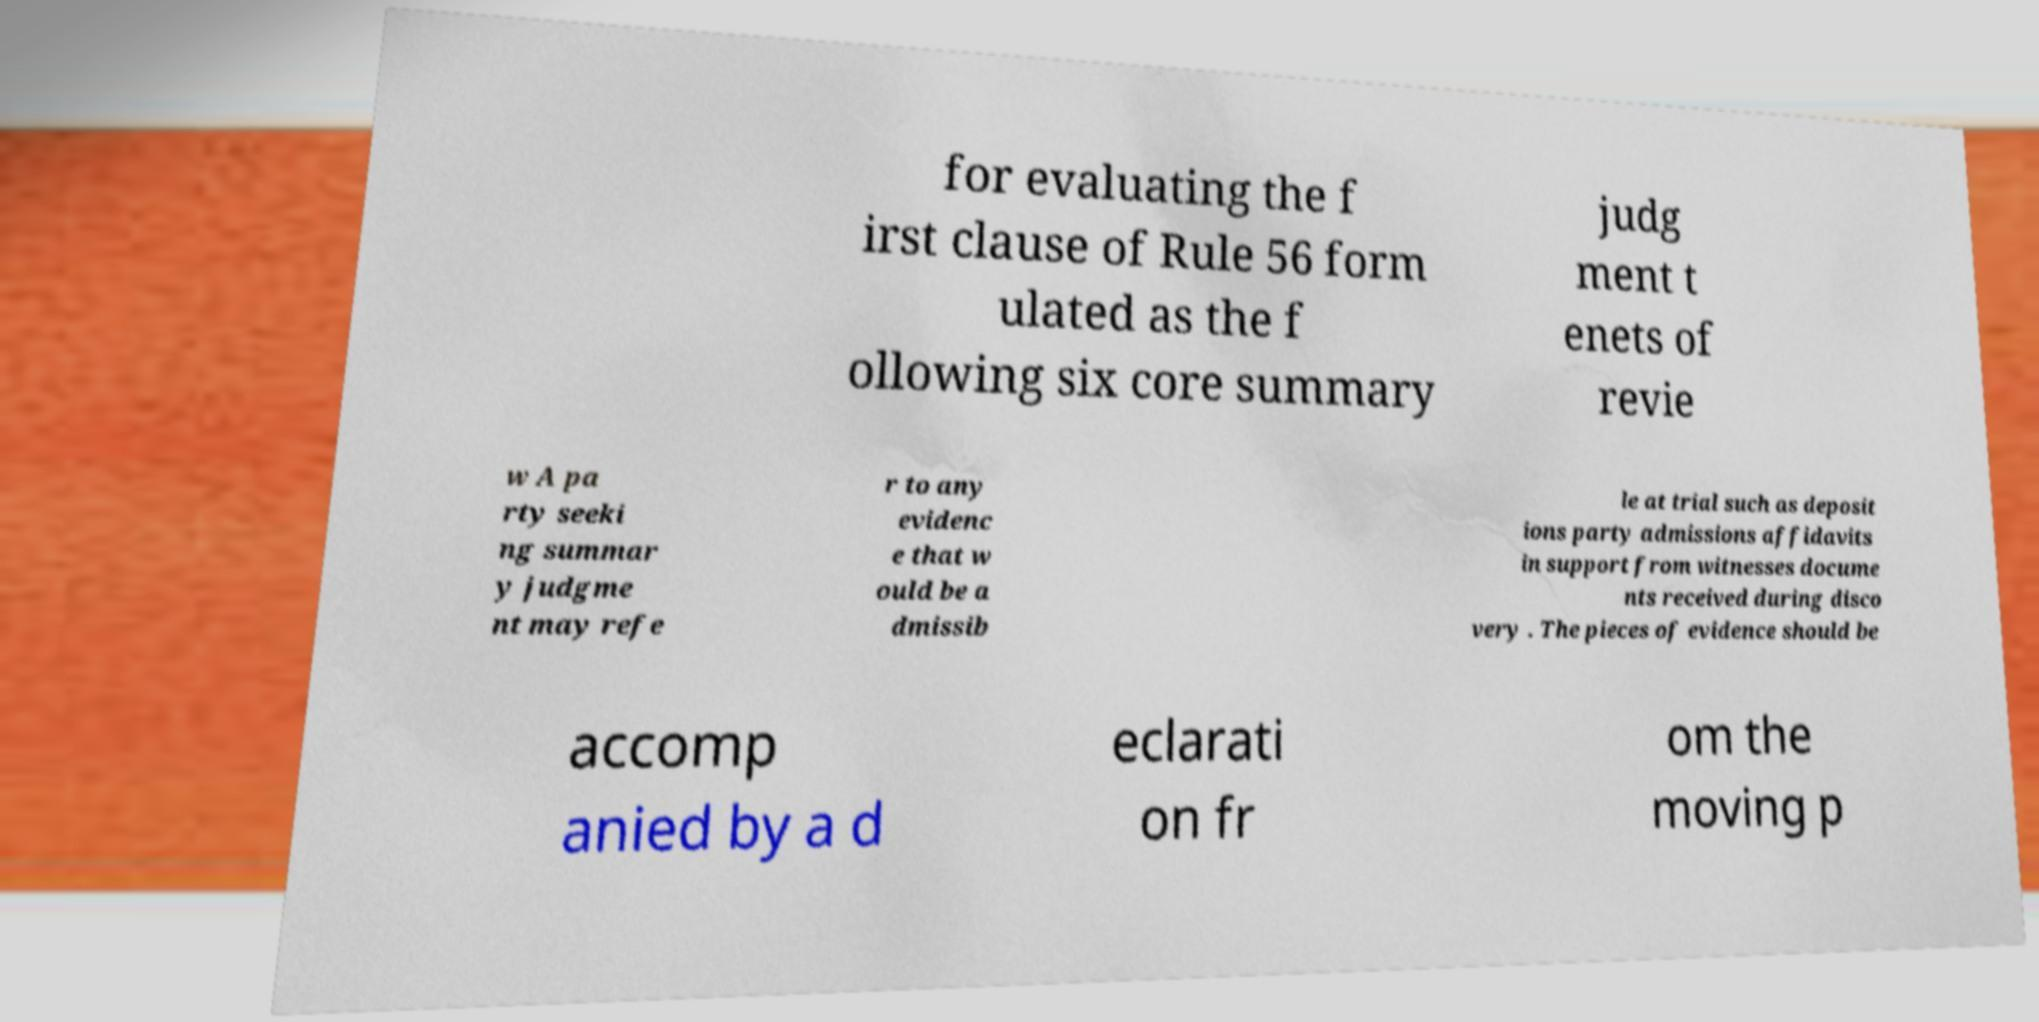Can you read and provide the text displayed in the image?This photo seems to have some interesting text. Can you extract and type it out for me? for evaluating the f irst clause of Rule 56 form ulated as the f ollowing six core summary judg ment t enets of revie w A pa rty seeki ng summar y judgme nt may refe r to any evidenc e that w ould be a dmissib le at trial such as deposit ions party admissions affidavits in support from witnesses docume nts received during disco very . The pieces of evidence should be accomp anied by a d eclarati on fr om the moving p 